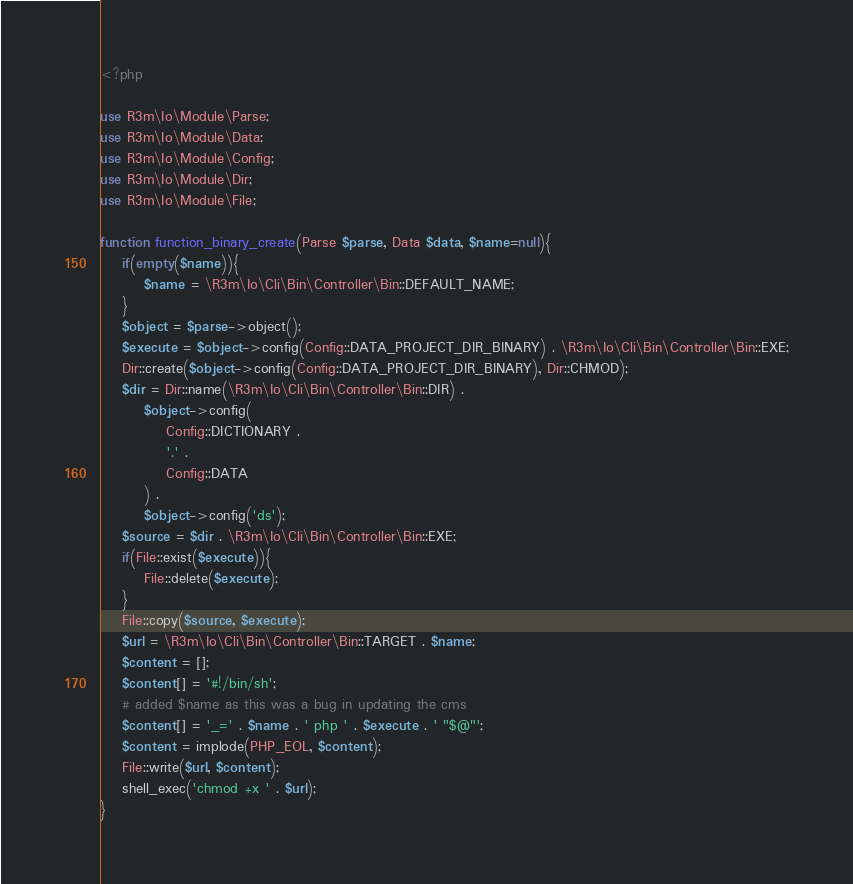Convert code to text. <code><loc_0><loc_0><loc_500><loc_500><_PHP_><?php

use R3m\Io\Module\Parse;
use R3m\Io\Module\Data;
use R3m\Io\Module\Config;
use R3m\Io\Module\Dir;
use R3m\Io\Module\File;

function function_binary_create(Parse $parse, Data $data, $name=null){    
    if(empty($name)){
        $name = \R3m\Io\Cli\Bin\Controller\Bin::DEFAULT_NAME;
    }
    $object = $parse->object();
    $execute = $object->config(Config::DATA_PROJECT_DIR_BINARY) . \R3m\Io\Cli\Bin\Controller\Bin::EXE;
    Dir::create($object->config(Config::DATA_PROJECT_DIR_BINARY), Dir::CHMOD);
    $dir = Dir::name(\R3m\Io\Cli\Bin\Controller\Bin::DIR) .
        $object->config(
            Config::DICTIONARY .
            '.' .
            Config::DATA
        ) .
        $object->config('ds');
    $source = $dir . \R3m\Io\Cli\Bin\Controller\Bin::EXE;      
    if(File::exist($execute)){
        File::delete($execute);
    }    
    File::copy($source, $execute);
    $url = \R3m\Io\Cli\Bin\Controller\Bin::TARGET . $name;
    $content = [];
    $content[] = '#!/bin/sh';
    # added $name as this was a bug in updating the cms
    $content[] = '_=' . $name . ' php ' . $execute . ' "$@"';
    $content = implode(PHP_EOL, $content);
    File::write($url, $content);
    shell_exec('chmod +x ' . $url);
}
</code> 